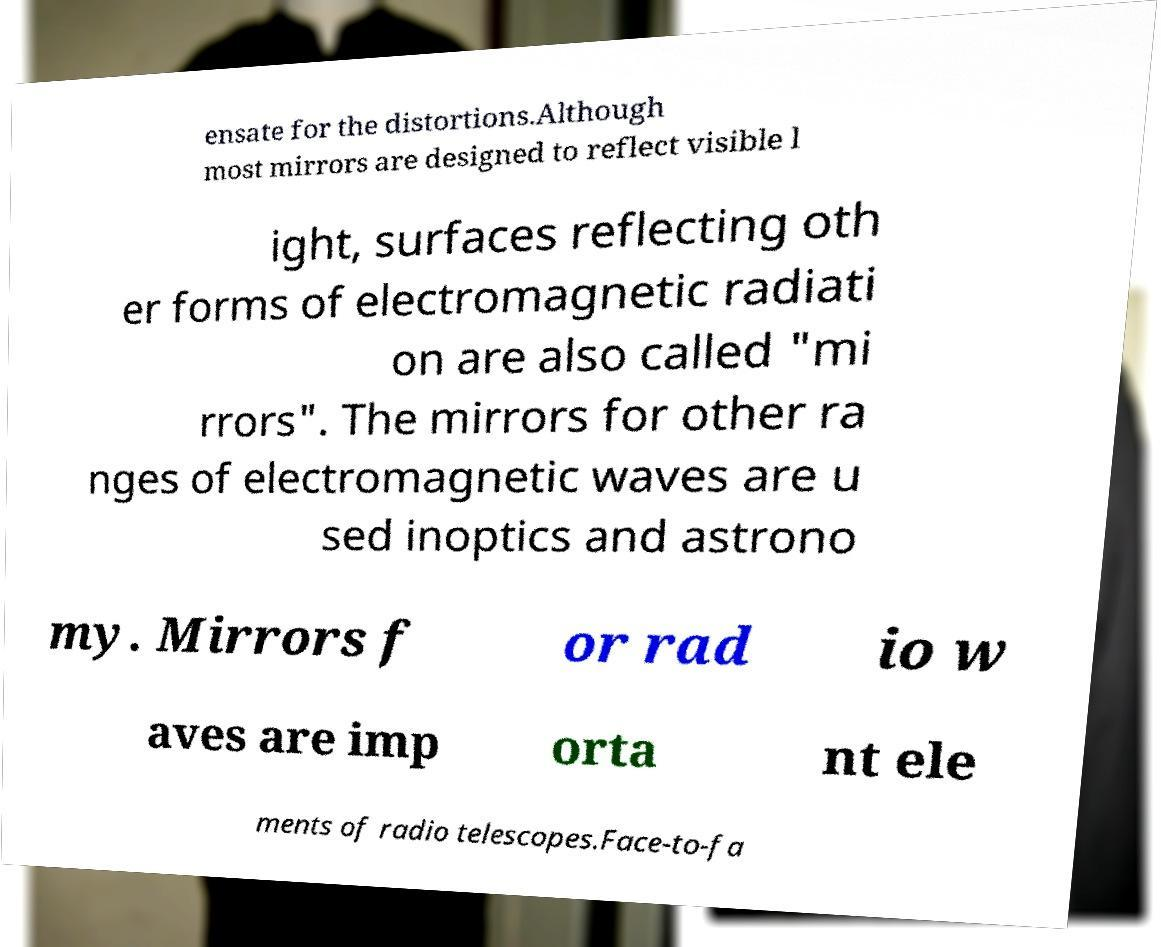I need the written content from this picture converted into text. Can you do that? ensate for the distortions.Although most mirrors are designed to reflect visible l ight, surfaces reflecting oth er forms of electromagnetic radiati on are also called "mi rrors". The mirrors for other ra nges of electromagnetic waves are u sed inoptics and astrono my. Mirrors f or rad io w aves are imp orta nt ele ments of radio telescopes.Face-to-fa 